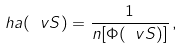Convert formula to latex. <formula><loc_0><loc_0><loc_500><loc_500>\ h a ( \ v S ) = \frac { 1 } { n [ \Phi ( \ v S ) ] } \, ,</formula> 